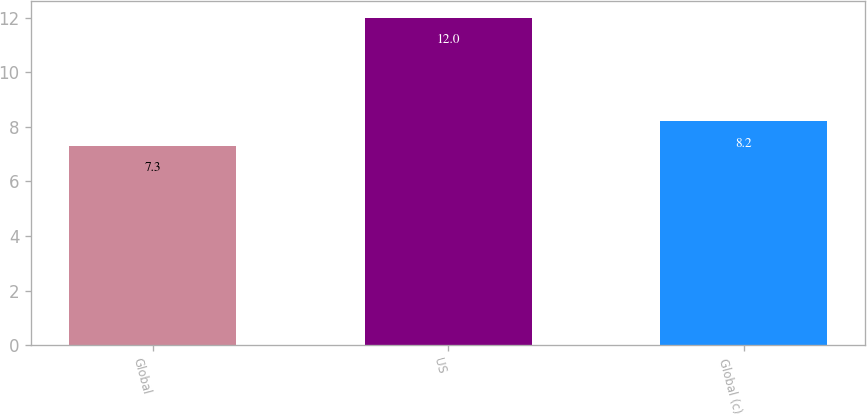<chart> <loc_0><loc_0><loc_500><loc_500><bar_chart><fcel>Global<fcel>US<fcel>Global (c)<nl><fcel>7.3<fcel>12<fcel>8.2<nl></chart> 